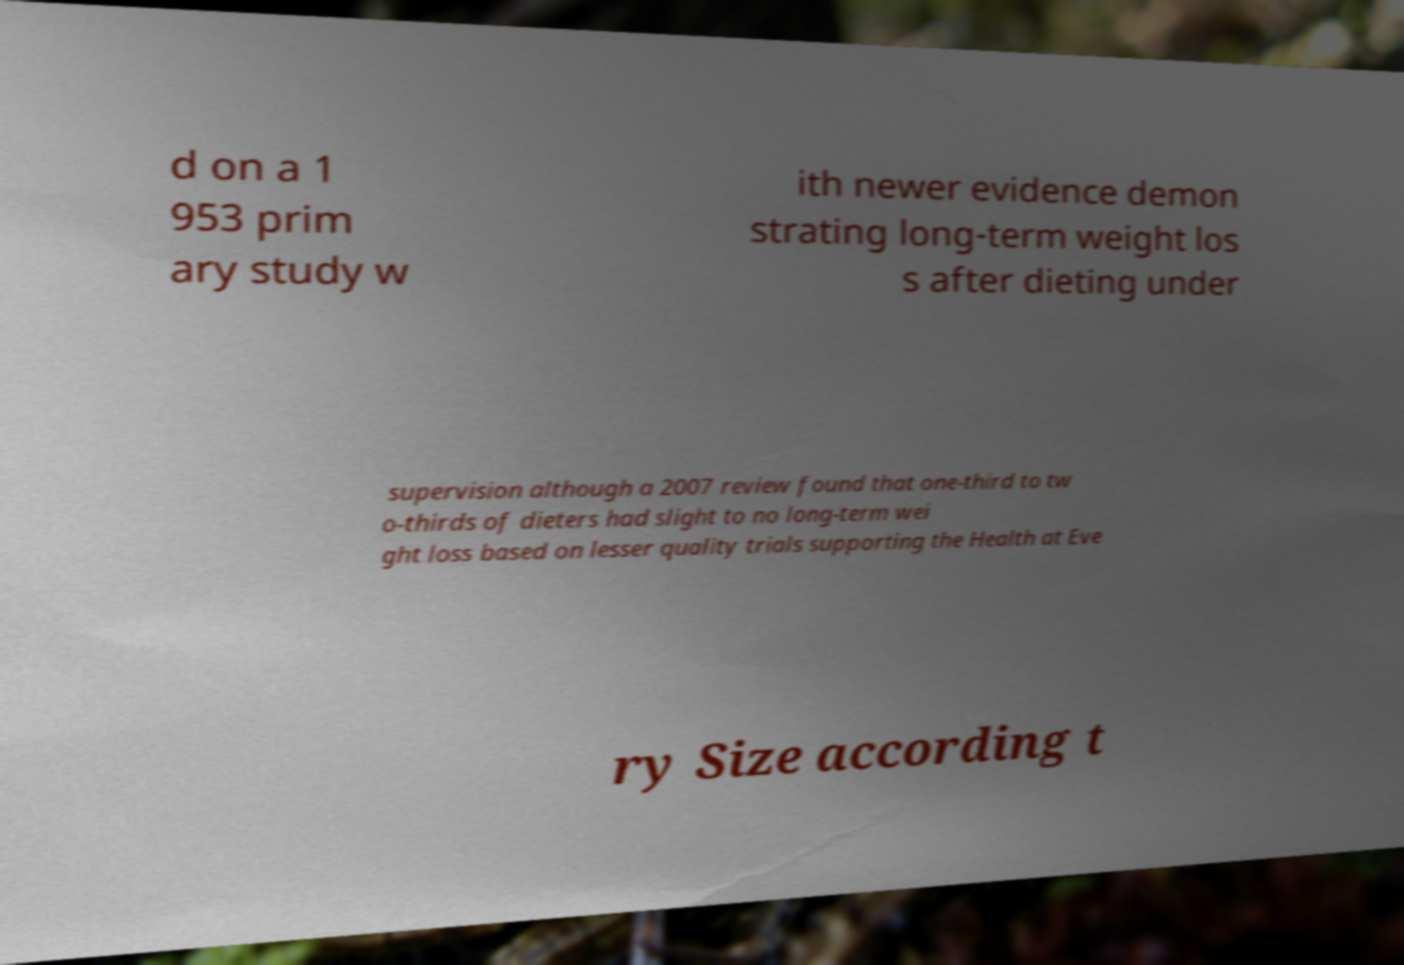Please read and relay the text visible in this image. What does it say? d on a 1 953 prim ary study w ith newer evidence demon strating long-term weight los s after dieting under supervision although a 2007 review found that one-third to tw o-thirds of dieters had slight to no long-term wei ght loss based on lesser quality trials supporting the Health at Eve ry Size according t 